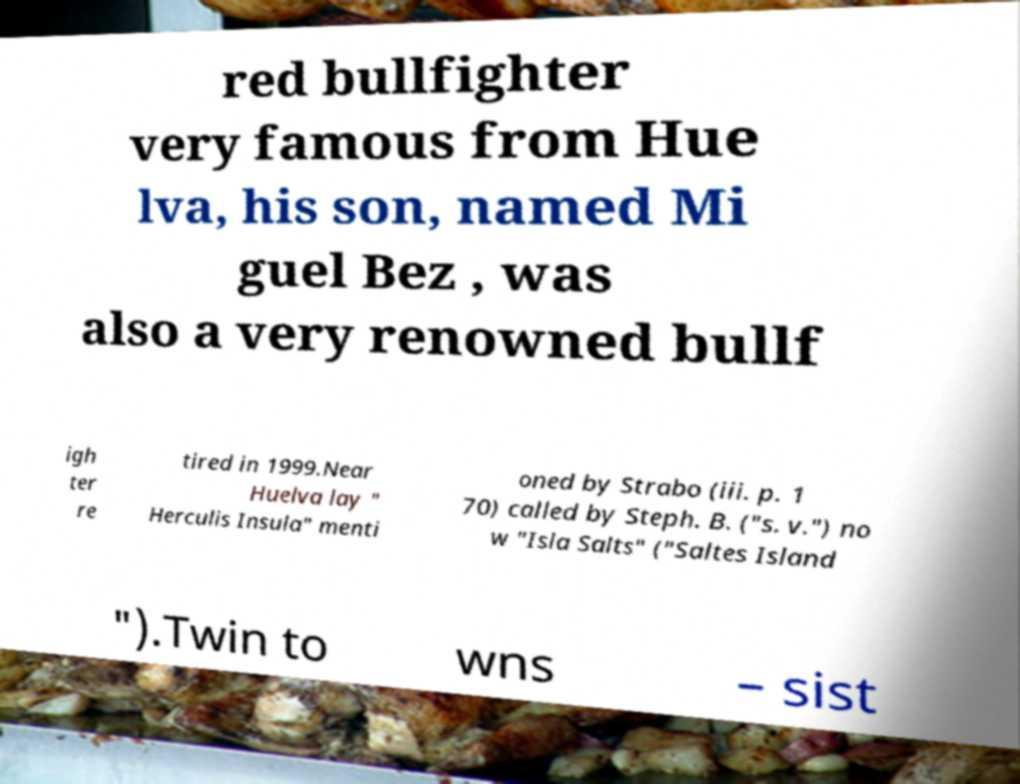What messages or text are displayed in this image? I need them in a readable, typed format. red bullfighter very famous from Hue lva, his son, named Mi guel Bez , was also a very renowned bullf igh ter re tired in 1999.Near Huelva lay " Herculis Insula" menti oned by Strabo (iii. p. 1 70) called by Steph. B. ("s. v.") no w "Isla Salts" ("Saltes Island ").Twin to wns – sist 